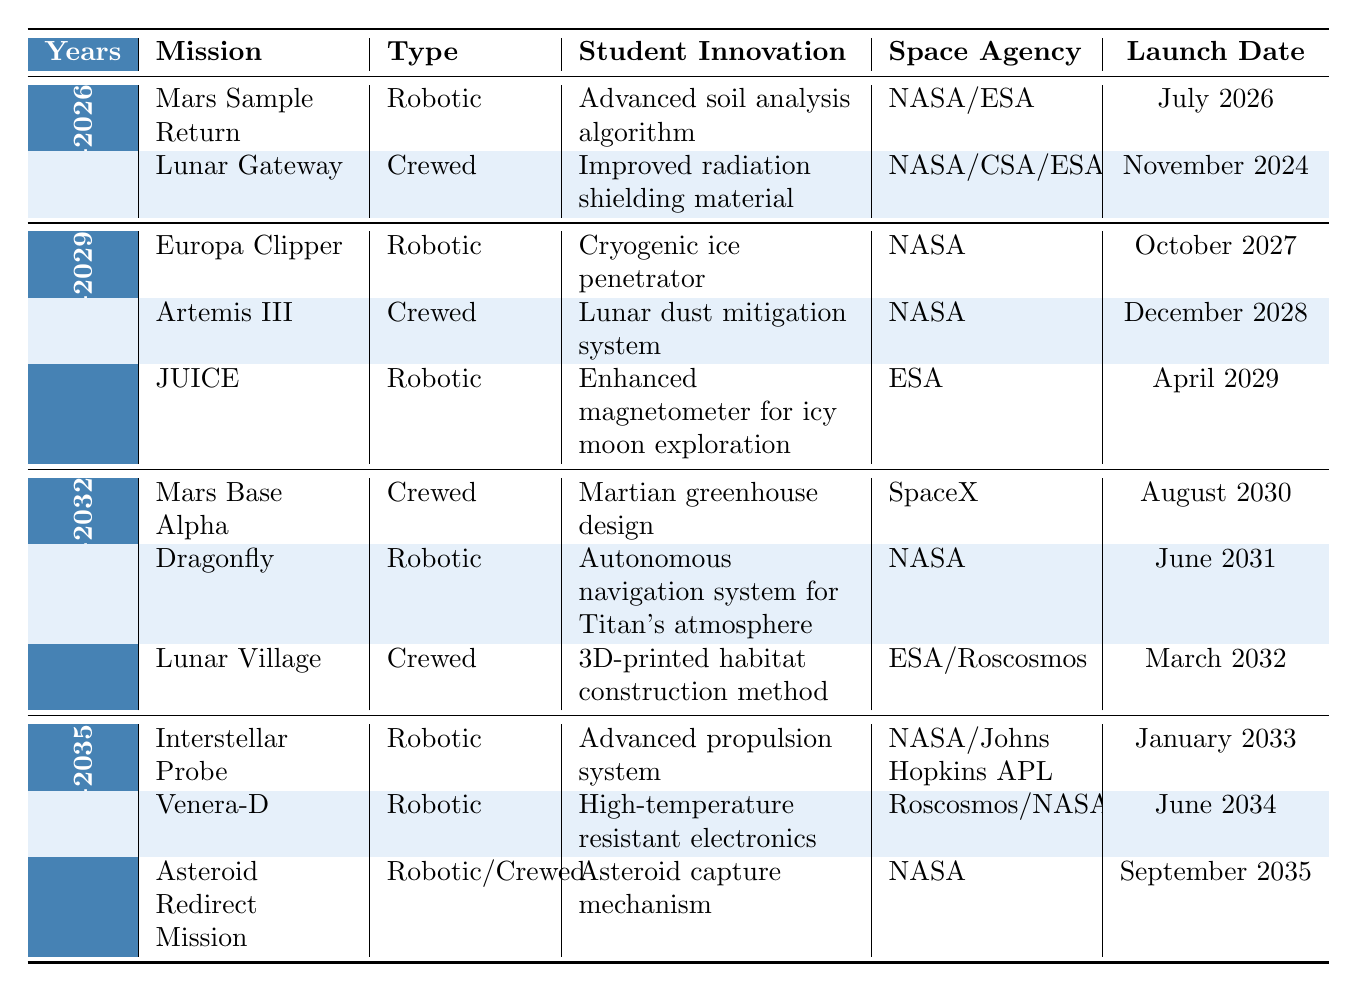What is the mission type for the Mars Sample Return? The table lists the mission type for Mars Sample Return as "Robotic" in the row for the years 2024-2026.
Answer: Robotic Which space agency is responsible for the Lunar Gateway mission? From the table, the space agencies involved in the Lunar Gateway mission are NASA, CSA, ESA, and JAXA as shown in the respective row for the years 2024-2026.
Answer: NASA/CSA/ESA/JAXA How many crewed missions are planned between 2024-2026? Looking at the table, there are two missions listed under the years 2024-2026, one of which is crewed (Lunar Gateway), while the other (Mars Sample Return) is robotic. Therefore, the total count of crewed missions is 1.
Answer: 1 What student innovation is featured in the Artemis III mission? The student innovation for Artemis III is "Lunar dust mitigation system," which can be found in the respective row under the years 2027-2029.
Answer: Lunar dust mitigation system Is there a robotic mission planned in 2031? Yes, the Dragonfly mission, which is a robotic mission, is scheduled to launch in June 2031 as indicated in the table.
Answer: Yes What is the launch date for the JUICE mission? The JUICE mission is planned to be launched in April 2029, according to the table.
Answer: April 2029 How many robotic missions are planned from 2030-2035? Checking the table, there are a total of four robotic missions listed: Interstellar Probe, Venera-D, Dragonfly, and JUICE. The missions that are either robotic or crewed do not count towards this total, therefore the count is 3.
Answer: 3 Which mission has the earliest launch date in the table? The earliest launch date according to the table is for the Lunar Gateway mission, scheduled for November 2024.
Answer: November 2024 Which space agencies are involved in the Mars Base Alpha mission? From the table, the Mars Base Alpha mission is operated by SpaceX, as no additional agencies are listed beside it.
Answer: SpaceX If the Artemis III mission is delayed by one year, when would it launch? The Artemis III mission is currently scheduled for December 2028. If it is delayed by one year, it would launch in December 2029.
Answer: December 2029 What is the difference in mission types between Mars Sample Return and Artemis III? Mars Sample Return is classified as "Robotic," while Artemis III is classified as "Crewed." The difference in type is that one is robotic and the other is crewed.
Answer: One is robotic; the other is crewed Which student innovation is connected to the Interstellar Probe? The student innovation linked to the Interstellar Probe mission is "Advanced propulsion system," as noted in the relevant row under the years 2033-2035.
Answer: Advanced propulsion system What total number of missions are planned for the years 2030-2032? There are three missions planned for the years 2030-2032: Mars Base Alpha, Dragonfly, and Lunar Village.
Answer: 3 Is it true that all missions listed after 2030 are robotic? No, it is false because at least one crewed mission, the Mars Base Alpha, is listed in the years 2030-2032.
Answer: No 